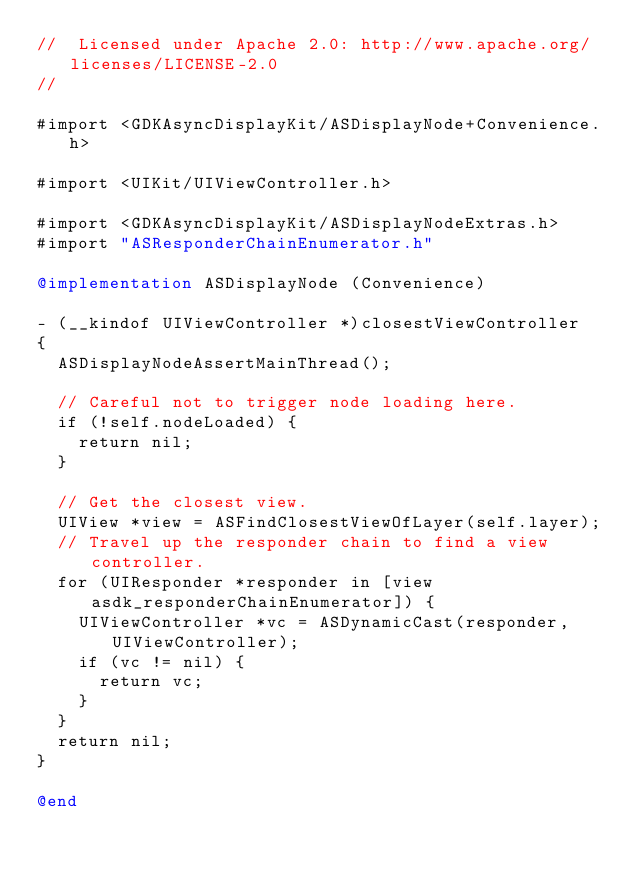<code> <loc_0><loc_0><loc_500><loc_500><_ObjectiveC_>//  Licensed under Apache 2.0: http://www.apache.org/licenses/LICENSE-2.0
//

#import <GDKAsyncDisplayKit/ASDisplayNode+Convenience.h>

#import <UIKit/UIViewController.h>

#import <GDKAsyncDisplayKit/ASDisplayNodeExtras.h>
#import "ASResponderChainEnumerator.h"

@implementation ASDisplayNode (Convenience)

- (__kindof UIViewController *)closestViewController
{
  ASDisplayNodeAssertMainThread();
  
  // Careful not to trigger node loading here.
  if (!self.nodeLoaded) {
    return nil;
  }

  // Get the closest view.
  UIView *view = ASFindClosestViewOfLayer(self.layer);
  // Travel up the responder chain to find a view controller.
  for (UIResponder *responder in [view asdk_responderChainEnumerator]) {
    UIViewController *vc = ASDynamicCast(responder, UIViewController);
    if (vc != nil) {
      return vc;
    }
  }
  return nil;
}

@end
</code> 